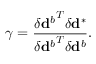<formula> <loc_0><loc_0><loc_500><loc_500>\gamma = \frac { { \delta d ^ { b } } ^ { T } \delta d ^ { * } } { { \delta d ^ { b } } ^ { T } \delta d ^ { b } } .</formula> 